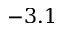Convert formula to latex. <formula><loc_0><loc_0><loc_500><loc_500>- 3 . 1</formula> 